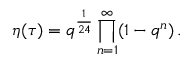<formula> <loc_0><loc_0><loc_500><loc_500>\eta ( \tau ) = q ^ { \frac { 1 } { 2 4 } } \prod _ { n = 1 } ^ { \infty } ( 1 - q ^ { n } ) \, .</formula> 